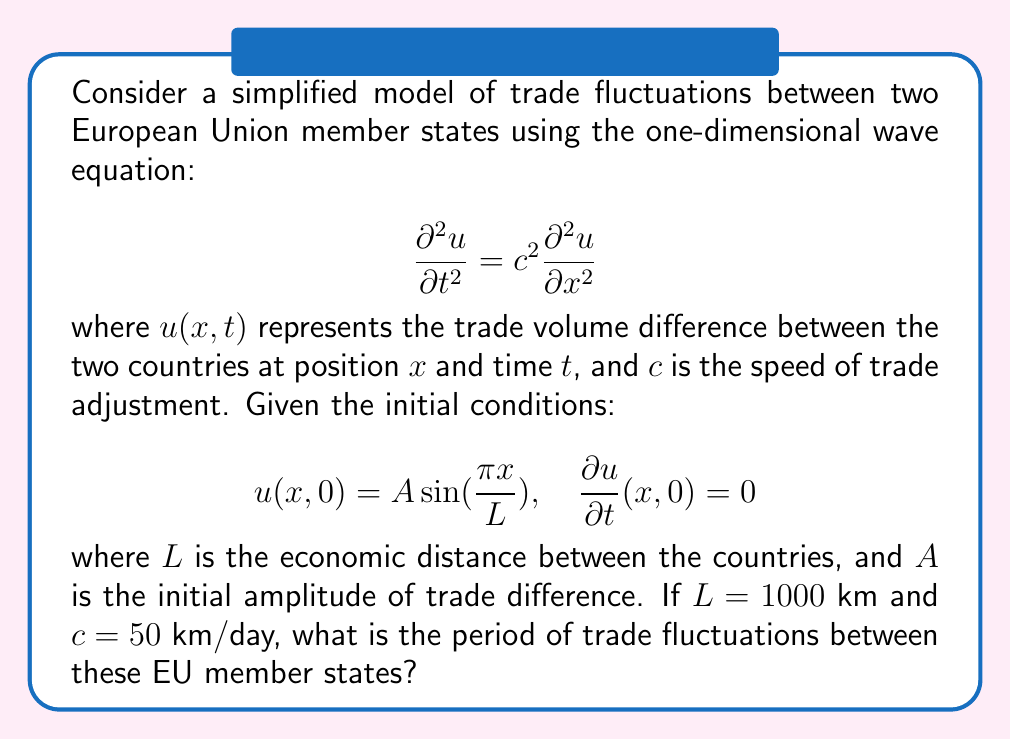What is the answer to this math problem? To solve this problem, we'll follow these steps:

1) The general solution to the wave equation with these initial conditions is:

   $$u(x,t) = A \sin(\frac{\pi x}{L}) \cos(\frac{c\pi t}{L})$$

2) The period $T$ of the oscillation is the time it takes for the cosine function to complete one full cycle. This occurs when:

   $$\frac{c\pi T}{L} = 2\pi$$

3) Solving for $T$:

   $$T = \frac{2L}{c}$$

4) Now, we can substitute the given values:

   $L = 1000$ km
   $c = 50$ km/day

5) Calculating $T$:

   $$T = \frac{2 \cdot 1000}{50} = 40$$ days

Therefore, the period of trade fluctuations between these EU member states is 40 days.
Answer: 40 days 